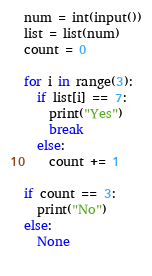<code> <loc_0><loc_0><loc_500><loc_500><_Python_>num = int(input())
list = list(num)
count = 0

for i in range(3):
  if list[i] == 7:
    print("Yes")
    break
  else:
    count += 1
    
if count == 3:
  print("No")
else:
  None
      </code> 